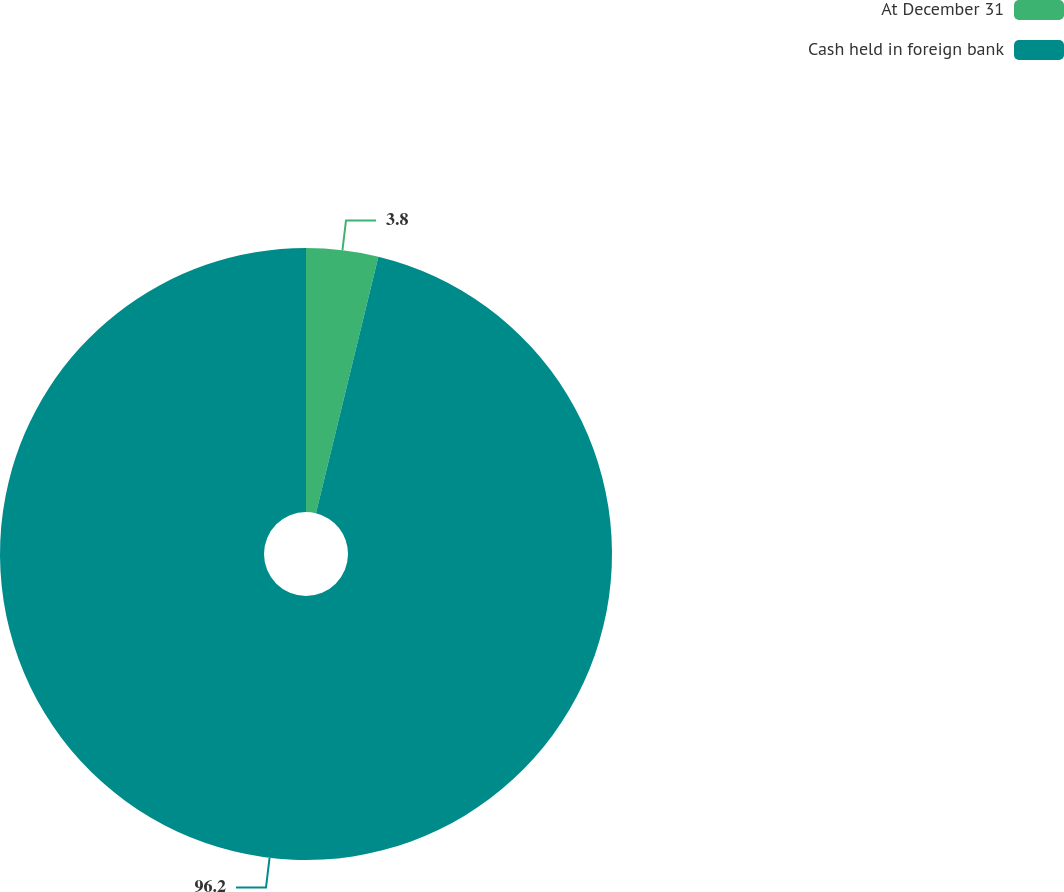Convert chart to OTSL. <chart><loc_0><loc_0><loc_500><loc_500><pie_chart><fcel>At December 31<fcel>Cash held in foreign bank<nl><fcel>3.8%<fcel>96.2%<nl></chart> 